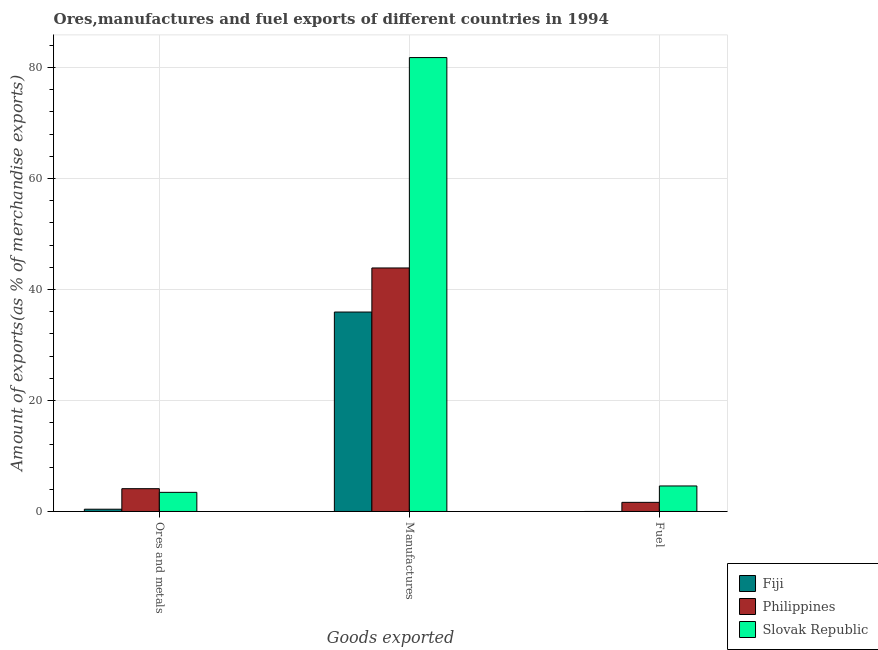How many groups of bars are there?
Your response must be concise. 3. How many bars are there on the 1st tick from the left?
Keep it short and to the point. 3. What is the label of the 3rd group of bars from the left?
Provide a succinct answer. Fuel. What is the percentage of manufactures exports in Philippines?
Offer a very short reply. 43.87. Across all countries, what is the maximum percentage of fuel exports?
Offer a very short reply. 4.6. Across all countries, what is the minimum percentage of ores and metals exports?
Offer a terse response. 0.41. In which country was the percentage of fuel exports maximum?
Your response must be concise. Slovak Republic. In which country was the percentage of manufactures exports minimum?
Give a very brief answer. Fiji. What is the total percentage of fuel exports in the graph?
Keep it short and to the point. 6.25. What is the difference between the percentage of manufactures exports in Fiji and that in Slovak Republic?
Offer a very short reply. -45.84. What is the difference between the percentage of manufactures exports in Philippines and the percentage of fuel exports in Slovak Republic?
Ensure brevity in your answer.  39.27. What is the average percentage of ores and metals exports per country?
Make the answer very short. 2.65. What is the difference between the percentage of fuel exports and percentage of manufactures exports in Philippines?
Your response must be concise. -42.23. In how many countries, is the percentage of fuel exports greater than 68 %?
Give a very brief answer. 0. What is the ratio of the percentage of manufactures exports in Fiji to that in Philippines?
Make the answer very short. 0.82. What is the difference between the highest and the second highest percentage of fuel exports?
Make the answer very short. 2.95. What is the difference between the highest and the lowest percentage of ores and metals exports?
Make the answer very short. 3.7. What does the 3rd bar from the left in Manufactures represents?
Provide a short and direct response. Slovak Republic. Is it the case that in every country, the sum of the percentage of ores and metals exports and percentage of manufactures exports is greater than the percentage of fuel exports?
Provide a succinct answer. Yes. What is the difference between two consecutive major ticks on the Y-axis?
Keep it short and to the point. 20. Are the values on the major ticks of Y-axis written in scientific E-notation?
Ensure brevity in your answer.  No. Does the graph contain any zero values?
Your answer should be very brief. No. Does the graph contain grids?
Your answer should be compact. Yes. How many legend labels are there?
Offer a very short reply. 3. How are the legend labels stacked?
Ensure brevity in your answer.  Vertical. What is the title of the graph?
Make the answer very short. Ores,manufactures and fuel exports of different countries in 1994. Does "Austria" appear as one of the legend labels in the graph?
Ensure brevity in your answer.  No. What is the label or title of the X-axis?
Provide a short and direct response. Goods exported. What is the label or title of the Y-axis?
Ensure brevity in your answer.  Amount of exports(as % of merchandise exports). What is the Amount of exports(as % of merchandise exports) in Fiji in Ores and metals?
Your answer should be compact. 0.41. What is the Amount of exports(as % of merchandise exports) in Philippines in Ores and metals?
Provide a short and direct response. 4.11. What is the Amount of exports(as % of merchandise exports) in Slovak Republic in Ores and metals?
Make the answer very short. 3.45. What is the Amount of exports(as % of merchandise exports) in Fiji in Manufactures?
Make the answer very short. 35.93. What is the Amount of exports(as % of merchandise exports) in Philippines in Manufactures?
Offer a terse response. 43.87. What is the Amount of exports(as % of merchandise exports) in Slovak Republic in Manufactures?
Offer a very short reply. 81.78. What is the Amount of exports(as % of merchandise exports) of Fiji in Fuel?
Provide a succinct answer. 0. What is the Amount of exports(as % of merchandise exports) of Philippines in Fuel?
Give a very brief answer. 1.65. What is the Amount of exports(as % of merchandise exports) of Slovak Republic in Fuel?
Provide a succinct answer. 4.6. Across all Goods exported, what is the maximum Amount of exports(as % of merchandise exports) of Fiji?
Provide a short and direct response. 35.93. Across all Goods exported, what is the maximum Amount of exports(as % of merchandise exports) in Philippines?
Provide a succinct answer. 43.87. Across all Goods exported, what is the maximum Amount of exports(as % of merchandise exports) in Slovak Republic?
Your response must be concise. 81.78. Across all Goods exported, what is the minimum Amount of exports(as % of merchandise exports) of Fiji?
Offer a terse response. 0. Across all Goods exported, what is the minimum Amount of exports(as % of merchandise exports) in Philippines?
Keep it short and to the point. 1.65. Across all Goods exported, what is the minimum Amount of exports(as % of merchandise exports) in Slovak Republic?
Your answer should be compact. 3.45. What is the total Amount of exports(as % of merchandise exports) in Fiji in the graph?
Give a very brief answer. 36.34. What is the total Amount of exports(as % of merchandise exports) of Philippines in the graph?
Your answer should be very brief. 49.63. What is the total Amount of exports(as % of merchandise exports) of Slovak Republic in the graph?
Offer a very short reply. 89.82. What is the difference between the Amount of exports(as % of merchandise exports) in Fiji in Ores and metals and that in Manufactures?
Make the answer very short. -35.52. What is the difference between the Amount of exports(as % of merchandise exports) in Philippines in Ores and metals and that in Manufactures?
Keep it short and to the point. -39.76. What is the difference between the Amount of exports(as % of merchandise exports) in Slovak Republic in Ores and metals and that in Manufactures?
Your answer should be very brief. -78.33. What is the difference between the Amount of exports(as % of merchandise exports) of Fiji in Ores and metals and that in Fuel?
Give a very brief answer. 0.41. What is the difference between the Amount of exports(as % of merchandise exports) of Philippines in Ores and metals and that in Fuel?
Give a very brief answer. 2.46. What is the difference between the Amount of exports(as % of merchandise exports) of Slovak Republic in Ores and metals and that in Fuel?
Your answer should be compact. -1.15. What is the difference between the Amount of exports(as % of merchandise exports) of Fiji in Manufactures and that in Fuel?
Provide a succinct answer. 35.93. What is the difference between the Amount of exports(as % of merchandise exports) of Philippines in Manufactures and that in Fuel?
Make the answer very short. 42.23. What is the difference between the Amount of exports(as % of merchandise exports) in Slovak Republic in Manufactures and that in Fuel?
Offer a terse response. 77.18. What is the difference between the Amount of exports(as % of merchandise exports) of Fiji in Ores and metals and the Amount of exports(as % of merchandise exports) of Philippines in Manufactures?
Provide a short and direct response. -43.46. What is the difference between the Amount of exports(as % of merchandise exports) in Fiji in Ores and metals and the Amount of exports(as % of merchandise exports) in Slovak Republic in Manufactures?
Make the answer very short. -81.37. What is the difference between the Amount of exports(as % of merchandise exports) of Philippines in Ores and metals and the Amount of exports(as % of merchandise exports) of Slovak Republic in Manufactures?
Your answer should be compact. -77.67. What is the difference between the Amount of exports(as % of merchandise exports) of Fiji in Ores and metals and the Amount of exports(as % of merchandise exports) of Philippines in Fuel?
Keep it short and to the point. -1.24. What is the difference between the Amount of exports(as % of merchandise exports) of Fiji in Ores and metals and the Amount of exports(as % of merchandise exports) of Slovak Republic in Fuel?
Your response must be concise. -4.19. What is the difference between the Amount of exports(as % of merchandise exports) in Philippines in Ores and metals and the Amount of exports(as % of merchandise exports) in Slovak Republic in Fuel?
Your answer should be very brief. -0.49. What is the difference between the Amount of exports(as % of merchandise exports) of Fiji in Manufactures and the Amount of exports(as % of merchandise exports) of Philippines in Fuel?
Give a very brief answer. 34.29. What is the difference between the Amount of exports(as % of merchandise exports) of Fiji in Manufactures and the Amount of exports(as % of merchandise exports) of Slovak Republic in Fuel?
Provide a succinct answer. 31.33. What is the difference between the Amount of exports(as % of merchandise exports) of Philippines in Manufactures and the Amount of exports(as % of merchandise exports) of Slovak Republic in Fuel?
Ensure brevity in your answer.  39.27. What is the average Amount of exports(as % of merchandise exports) of Fiji per Goods exported?
Your response must be concise. 12.11. What is the average Amount of exports(as % of merchandise exports) of Philippines per Goods exported?
Provide a succinct answer. 16.54. What is the average Amount of exports(as % of merchandise exports) of Slovak Republic per Goods exported?
Make the answer very short. 29.94. What is the difference between the Amount of exports(as % of merchandise exports) in Fiji and Amount of exports(as % of merchandise exports) in Philippines in Ores and metals?
Make the answer very short. -3.7. What is the difference between the Amount of exports(as % of merchandise exports) in Fiji and Amount of exports(as % of merchandise exports) in Slovak Republic in Ores and metals?
Offer a very short reply. -3.04. What is the difference between the Amount of exports(as % of merchandise exports) of Philippines and Amount of exports(as % of merchandise exports) of Slovak Republic in Ores and metals?
Ensure brevity in your answer.  0.66. What is the difference between the Amount of exports(as % of merchandise exports) in Fiji and Amount of exports(as % of merchandise exports) in Philippines in Manufactures?
Make the answer very short. -7.94. What is the difference between the Amount of exports(as % of merchandise exports) of Fiji and Amount of exports(as % of merchandise exports) of Slovak Republic in Manufactures?
Your answer should be compact. -45.84. What is the difference between the Amount of exports(as % of merchandise exports) of Philippines and Amount of exports(as % of merchandise exports) of Slovak Republic in Manufactures?
Provide a short and direct response. -37.91. What is the difference between the Amount of exports(as % of merchandise exports) of Fiji and Amount of exports(as % of merchandise exports) of Philippines in Fuel?
Ensure brevity in your answer.  -1.65. What is the difference between the Amount of exports(as % of merchandise exports) of Fiji and Amount of exports(as % of merchandise exports) of Slovak Republic in Fuel?
Make the answer very short. -4.6. What is the difference between the Amount of exports(as % of merchandise exports) of Philippines and Amount of exports(as % of merchandise exports) of Slovak Republic in Fuel?
Your answer should be compact. -2.95. What is the ratio of the Amount of exports(as % of merchandise exports) in Fiji in Ores and metals to that in Manufactures?
Offer a terse response. 0.01. What is the ratio of the Amount of exports(as % of merchandise exports) in Philippines in Ores and metals to that in Manufactures?
Provide a succinct answer. 0.09. What is the ratio of the Amount of exports(as % of merchandise exports) in Slovak Republic in Ores and metals to that in Manufactures?
Your answer should be very brief. 0.04. What is the ratio of the Amount of exports(as % of merchandise exports) in Fiji in Ores and metals to that in Fuel?
Your answer should be very brief. 304.83. What is the ratio of the Amount of exports(as % of merchandise exports) of Philippines in Ores and metals to that in Fuel?
Your response must be concise. 2.5. What is the ratio of the Amount of exports(as % of merchandise exports) in Slovak Republic in Ores and metals to that in Fuel?
Make the answer very short. 0.75. What is the ratio of the Amount of exports(as % of merchandise exports) of Fiji in Manufactures to that in Fuel?
Keep it short and to the point. 2.68e+04. What is the ratio of the Amount of exports(as % of merchandise exports) of Philippines in Manufactures to that in Fuel?
Make the answer very short. 26.65. What is the ratio of the Amount of exports(as % of merchandise exports) in Slovak Republic in Manufactures to that in Fuel?
Make the answer very short. 17.79. What is the difference between the highest and the second highest Amount of exports(as % of merchandise exports) in Fiji?
Keep it short and to the point. 35.52. What is the difference between the highest and the second highest Amount of exports(as % of merchandise exports) in Philippines?
Provide a succinct answer. 39.76. What is the difference between the highest and the second highest Amount of exports(as % of merchandise exports) in Slovak Republic?
Offer a terse response. 77.18. What is the difference between the highest and the lowest Amount of exports(as % of merchandise exports) of Fiji?
Provide a short and direct response. 35.93. What is the difference between the highest and the lowest Amount of exports(as % of merchandise exports) of Philippines?
Your response must be concise. 42.23. What is the difference between the highest and the lowest Amount of exports(as % of merchandise exports) in Slovak Republic?
Your answer should be very brief. 78.33. 